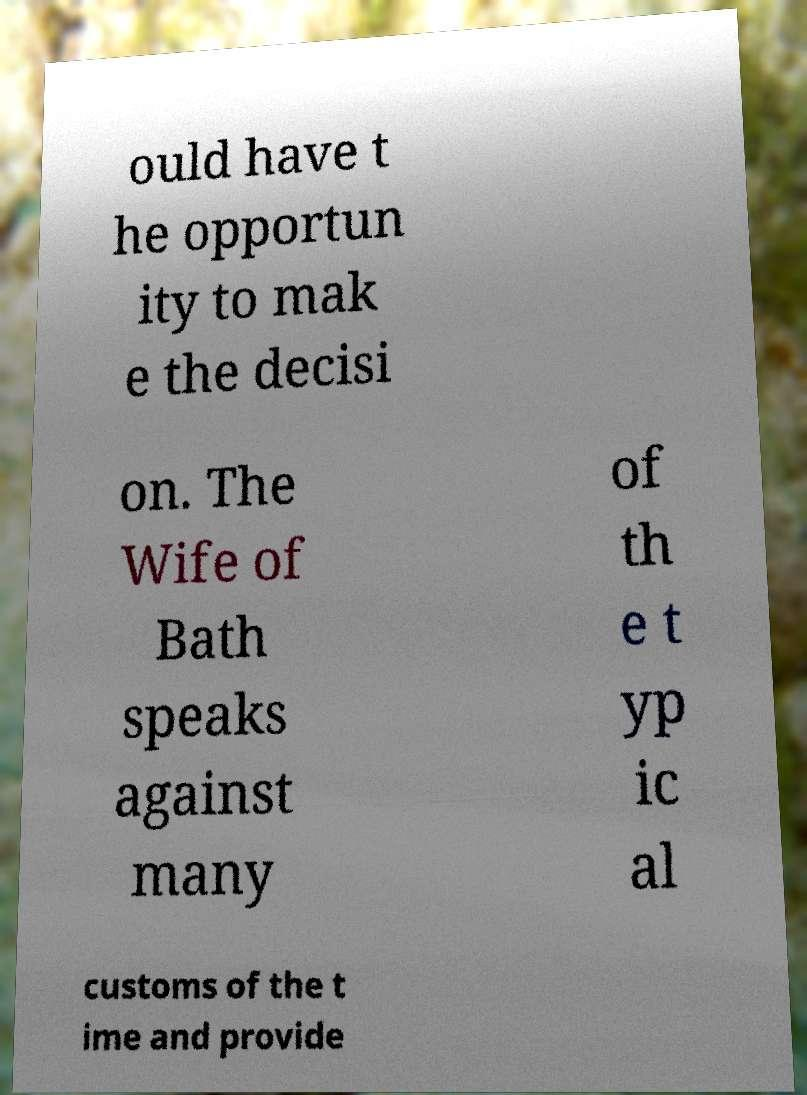Please identify and transcribe the text found in this image. ould have t he opportun ity to mak e the decisi on. The Wife of Bath speaks against many of th e t yp ic al customs of the t ime and provide 